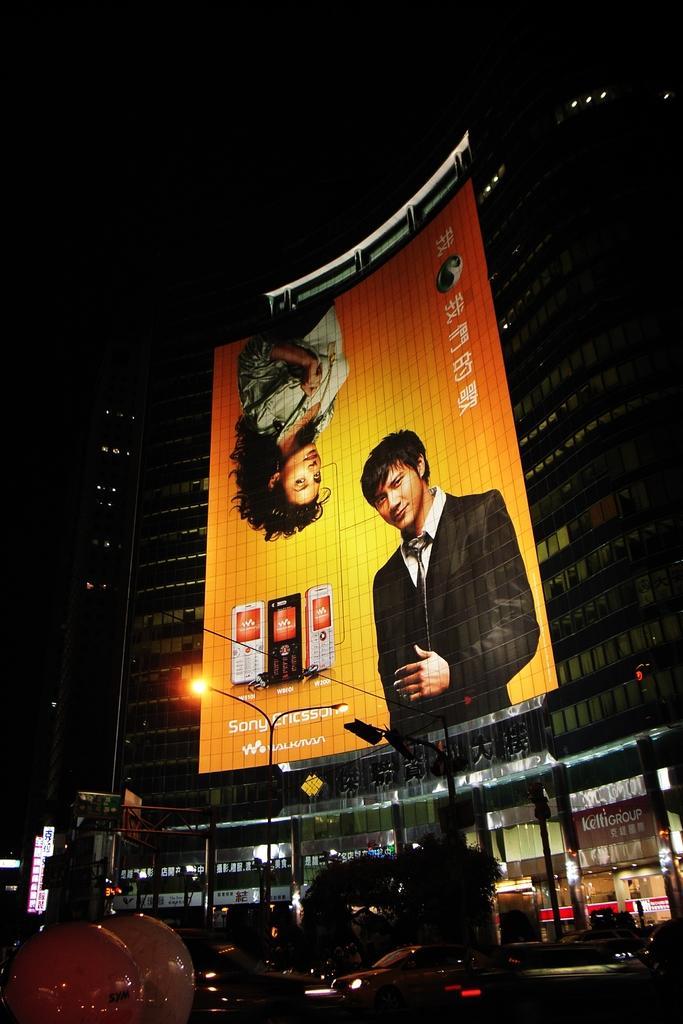Please provide a concise description of this image. In this image we can see a banner on a building containing some pictures and text on it. On the bottom of the image we can see a street pole, a signboard, trees and some vehicles on the road. 